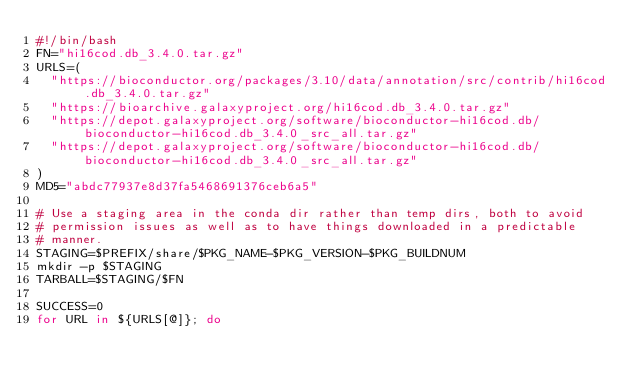Convert code to text. <code><loc_0><loc_0><loc_500><loc_500><_Bash_>#!/bin/bash
FN="hi16cod.db_3.4.0.tar.gz"
URLS=(
  "https://bioconductor.org/packages/3.10/data/annotation/src/contrib/hi16cod.db_3.4.0.tar.gz"
  "https://bioarchive.galaxyproject.org/hi16cod.db_3.4.0.tar.gz"
  "https://depot.galaxyproject.org/software/bioconductor-hi16cod.db/bioconductor-hi16cod.db_3.4.0_src_all.tar.gz"
  "https://depot.galaxyproject.org/software/bioconductor-hi16cod.db/bioconductor-hi16cod.db_3.4.0_src_all.tar.gz"
)
MD5="abdc77937e8d37fa5468691376ceb6a5"

# Use a staging area in the conda dir rather than temp dirs, both to avoid
# permission issues as well as to have things downloaded in a predictable
# manner.
STAGING=$PREFIX/share/$PKG_NAME-$PKG_VERSION-$PKG_BUILDNUM
mkdir -p $STAGING
TARBALL=$STAGING/$FN

SUCCESS=0
for URL in ${URLS[@]}; do</code> 